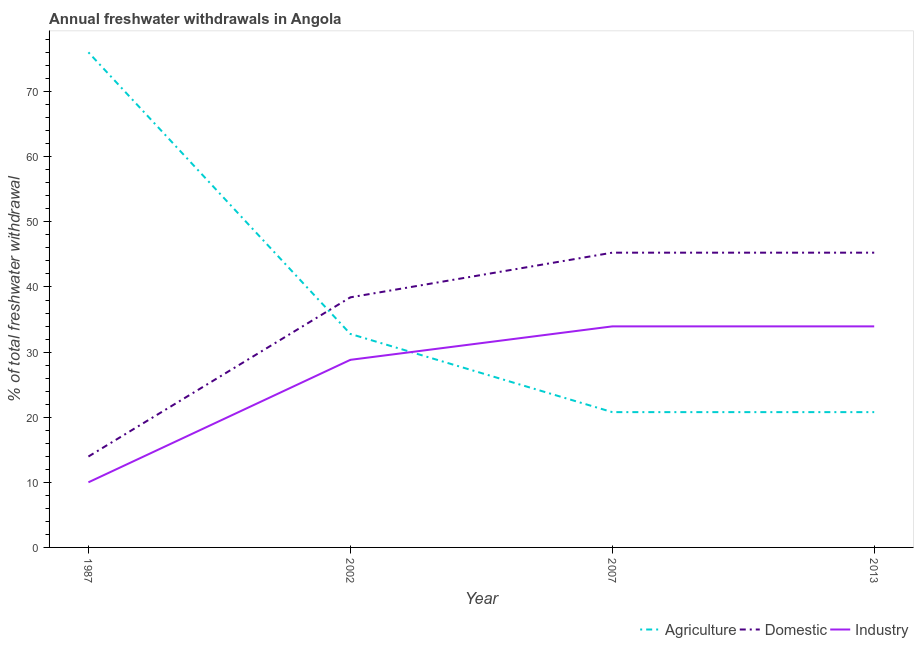How many different coloured lines are there?
Make the answer very short. 3. Does the line corresponding to percentage of freshwater withdrawal for industry intersect with the line corresponding to percentage of freshwater withdrawal for domestic purposes?
Give a very brief answer. No. Is the number of lines equal to the number of legend labels?
Provide a short and direct response. Yes. What is the percentage of freshwater withdrawal for industry in 2013?
Keep it short and to the point. 33.95. Across all years, what is the maximum percentage of freshwater withdrawal for domestic purposes?
Your answer should be very brief. 45.27. Across all years, what is the minimum percentage of freshwater withdrawal for industry?
Keep it short and to the point. 10. In which year was the percentage of freshwater withdrawal for domestic purposes maximum?
Make the answer very short. 2007. What is the total percentage of freshwater withdrawal for agriculture in the graph?
Your answer should be very brief. 150.39. What is the difference between the percentage of freshwater withdrawal for domestic purposes in 2002 and that in 2013?
Provide a succinct answer. -6.86. What is the difference between the percentage of freshwater withdrawal for domestic purposes in 2013 and the percentage of freshwater withdrawal for industry in 2007?
Your answer should be compact. 11.32. What is the average percentage of freshwater withdrawal for industry per year?
Offer a very short reply. 26.68. In the year 2007, what is the difference between the percentage of freshwater withdrawal for domestic purposes and percentage of freshwater withdrawal for industry?
Offer a very short reply. 11.32. In how many years, is the percentage of freshwater withdrawal for industry greater than 74 %?
Ensure brevity in your answer.  0. What is the ratio of the percentage of freshwater withdrawal for agriculture in 1987 to that in 2013?
Offer a terse response. 3.66. What is the difference between the highest and the second highest percentage of freshwater withdrawal for industry?
Provide a short and direct response. 0. What is the difference between the highest and the lowest percentage of freshwater withdrawal for agriculture?
Give a very brief answer. 55.26. In how many years, is the percentage of freshwater withdrawal for agriculture greater than the average percentage of freshwater withdrawal for agriculture taken over all years?
Your answer should be compact. 1. Is it the case that in every year, the sum of the percentage of freshwater withdrawal for agriculture and percentage of freshwater withdrawal for domestic purposes is greater than the percentage of freshwater withdrawal for industry?
Your response must be concise. Yes. Does the percentage of freshwater withdrawal for domestic purposes monotonically increase over the years?
Provide a succinct answer. No. Are the values on the major ticks of Y-axis written in scientific E-notation?
Keep it short and to the point. No. How many legend labels are there?
Offer a very short reply. 3. How are the legend labels stacked?
Offer a terse response. Horizontal. What is the title of the graph?
Your answer should be compact. Annual freshwater withdrawals in Angola. What is the label or title of the Y-axis?
Keep it short and to the point. % of total freshwater withdrawal. What is the % of total freshwater withdrawal in Agriculture in 1987?
Make the answer very short. 76.04. What is the % of total freshwater withdrawal of Domestic in 1987?
Your answer should be very brief. 13.96. What is the % of total freshwater withdrawal of Industry in 1987?
Your answer should be compact. 10. What is the % of total freshwater withdrawal in Agriculture in 2002?
Your response must be concise. 32.79. What is the % of total freshwater withdrawal of Domestic in 2002?
Your answer should be very brief. 38.41. What is the % of total freshwater withdrawal of Industry in 2002?
Offer a terse response. 28.81. What is the % of total freshwater withdrawal of Agriculture in 2007?
Offer a terse response. 20.78. What is the % of total freshwater withdrawal of Domestic in 2007?
Provide a succinct answer. 45.27. What is the % of total freshwater withdrawal in Industry in 2007?
Your answer should be very brief. 33.95. What is the % of total freshwater withdrawal in Agriculture in 2013?
Provide a short and direct response. 20.78. What is the % of total freshwater withdrawal of Domestic in 2013?
Your response must be concise. 45.27. What is the % of total freshwater withdrawal of Industry in 2013?
Offer a terse response. 33.95. Across all years, what is the maximum % of total freshwater withdrawal in Agriculture?
Provide a short and direct response. 76.04. Across all years, what is the maximum % of total freshwater withdrawal of Domestic?
Ensure brevity in your answer.  45.27. Across all years, what is the maximum % of total freshwater withdrawal of Industry?
Offer a very short reply. 33.95. Across all years, what is the minimum % of total freshwater withdrawal of Agriculture?
Provide a succinct answer. 20.78. Across all years, what is the minimum % of total freshwater withdrawal in Domestic?
Your answer should be very brief. 13.96. What is the total % of total freshwater withdrawal in Agriculture in the graph?
Your answer should be very brief. 150.39. What is the total % of total freshwater withdrawal of Domestic in the graph?
Ensure brevity in your answer.  142.91. What is the total % of total freshwater withdrawal in Industry in the graph?
Provide a short and direct response. 106.71. What is the difference between the % of total freshwater withdrawal in Agriculture in 1987 and that in 2002?
Give a very brief answer. 43.25. What is the difference between the % of total freshwater withdrawal in Domestic in 1987 and that in 2002?
Provide a succinct answer. -24.45. What is the difference between the % of total freshwater withdrawal in Industry in 1987 and that in 2002?
Offer a very short reply. -18.81. What is the difference between the % of total freshwater withdrawal of Agriculture in 1987 and that in 2007?
Provide a succinct answer. 55.26. What is the difference between the % of total freshwater withdrawal of Domestic in 1987 and that in 2007?
Your answer should be very brief. -31.31. What is the difference between the % of total freshwater withdrawal in Industry in 1987 and that in 2007?
Offer a very short reply. -23.95. What is the difference between the % of total freshwater withdrawal of Agriculture in 1987 and that in 2013?
Keep it short and to the point. 55.26. What is the difference between the % of total freshwater withdrawal of Domestic in 1987 and that in 2013?
Offer a very short reply. -31.31. What is the difference between the % of total freshwater withdrawal in Industry in 1987 and that in 2013?
Offer a very short reply. -23.95. What is the difference between the % of total freshwater withdrawal of Agriculture in 2002 and that in 2007?
Offer a terse response. 12.01. What is the difference between the % of total freshwater withdrawal of Domestic in 2002 and that in 2007?
Give a very brief answer. -6.86. What is the difference between the % of total freshwater withdrawal in Industry in 2002 and that in 2007?
Ensure brevity in your answer.  -5.14. What is the difference between the % of total freshwater withdrawal in Agriculture in 2002 and that in 2013?
Provide a short and direct response. 12.01. What is the difference between the % of total freshwater withdrawal in Domestic in 2002 and that in 2013?
Make the answer very short. -6.86. What is the difference between the % of total freshwater withdrawal of Industry in 2002 and that in 2013?
Your response must be concise. -5.14. What is the difference between the % of total freshwater withdrawal of Agriculture in 2007 and that in 2013?
Your answer should be very brief. 0. What is the difference between the % of total freshwater withdrawal of Domestic in 2007 and that in 2013?
Your answer should be compact. 0. What is the difference between the % of total freshwater withdrawal in Industry in 2007 and that in 2013?
Your answer should be compact. 0. What is the difference between the % of total freshwater withdrawal of Agriculture in 1987 and the % of total freshwater withdrawal of Domestic in 2002?
Make the answer very short. 37.63. What is the difference between the % of total freshwater withdrawal of Agriculture in 1987 and the % of total freshwater withdrawal of Industry in 2002?
Make the answer very short. 47.23. What is the difference between the % of total freshwater withdrawal in Domestic in 1987 and the % of total freshwater withdrawal in Industry in 2002?
Your response must be concise. -14.85. What is the difference between the % of total freshwater withdrawal of Agriculture in 1987 and the % of total freshwater withdrawal of Domestic in 2007?
Offer a terse response. 30.77. What is the difference between the % of total freshwater withdrawal of Agriculture in 1987 and the % of total freshwater withdrawal of Industry in 2007?
Offer a very short reply. 42.09. What is the difference between the % of total freshwater withdrawal in Domestic in 1987 and the % of total freshwater withdrawal in Industry in 2007?
Offer a terse response. -19.99. What is the difference between the % of total freshwater withdrawal of Agriculture in 1987 and the % of total freshwater withdrawal of Domestic in 2013?
Your answer should be very brief. 30.77. What is the difference between the % of total freshwater withdrawal of Agriculture in 1987 and the % of total freshwater withdrawal of Industry in 2013?
Make the answer very short. 42.09. What is the difference between the % of total freshwater withdrawal of Domestic in 1987 and the % of total freshwater withdrawal of Industry in 2013?
Your answer should be compact. -19.99. What is the difference between the % of total freshwater withdrawal in Agriculture in 2002 and the % of total freshwater withdrawal in Domestic in 2007?
Give a very brief answer. -12.48. What is the difference between the % of total freshwater withdrawal in Agriculture in 2002 and the % of total freshwater withdrawal in Industry in 2007?
Keep it short and to the point. -1.16. What is the difference between the % of total freshwater withdrawal in Domestic in 2002 and the % of total freshwater withdrawal in Industry in 2007?
Your response must be concise. 4.46. What is the difference between the % of total freshwater withdrawal of Agriculture in 2002 and the % of total freshwater withdrawal of Domestic in 2013?
Provide a succinct answer. -12.48. What is the difference between the % of total freshwater withdrawal in Agriculture in 2002 and the % of total freshwater withdrawal in Industry in 2013?
Give a very brief answer. -1.16. What is the difference between the % of total freshwater withdrawal in Domestic in 2002 and the % of total freshwater withdrawal in Industry in 2013?
Give a very brief answer. 4.46. What is the difference between the % of total freshwater withdrawal of Agriculture in 2007 and the % of total freshwater withdrawal of Domestic in 2013?
Keep it short and to the point. -24.49. What is the difference between the % of total freshwater withdrawal in Agriculture in 2007 and the % of total freshwater withdrawal in Industry in 2013?
Offer a terse response. -13.17. What is the difference between the % of total freshwater withdrawal of Domestic in 2007 and the % of total freshwater withdrawal of Industry in 2013?
Offer a very short reply. 11.32. What is the average % of total freshwater withdrawal in Agriculture per year?
Provide a succinct answer. 37.6. What is the average % of total freshwater withdrawal of Domestic per year?
Provide a short and direct response. 35.73. What is the average % of total freshwater withdrawal of Industry per year?
Your response must be concise. 26.68. In the year 1987, what is the difference between the % of total freshwater withdrawal in Agriculture and % of total freshwater withdrawal in Domestic?
Provide a succinct answer. 62.08. In the year 1987, what is the difference between the % of total freshwater withdrawal of Agriculture and % of total freshwater withdrawal of Industry?
Give a very brief answer. 66.04. In the year 1987, what is the difference between the % of total freshwater withdrawal of Domestic and % of total freshwater withdrawal of Industry?
Your response must be concise. 3.96. In the year 2002, what is the difference between the % of total freshwater withdrawal in Agriculture and % of total freshwater withdrawal in Domestic?
Offer a terse response. -5.62. In the year 2002, what is the difference between the % of total freshwater withdrawal in Agriculture and % of total freshwater withdrawal in Industry?
Make the answer very short. 3.98. In the year 2007, what is the difference between the % of total freshwater withdrawal in Agriculture and % of total freshwater withdrawal in Domestic?
Provide a short and direct response. -24.49. In the year 2007, what is the difference between the % of total freshwater withdrawal in Agriculture and % of total freshwater withdrawal in Industry?
Provide a succinct answer. -13.17. In the year 2007, what is the difference between the % of total freshwater withdrawal in Domestic and % of total freshwater withdrawal in Industry?
Your answer should be compact. 11.32. In the year 2013, what is the difference between the % of total freshwater withdrawal of Agriculture and % of total freshwater withdrawal of Domestic?
Your response must be concise. -24.49. In the year 2013, what is the difference between the % of total freshwater withdrawal in Agriculture and % of total freshwater withdrawal in Industry?
Provide a succinct answer. -13.17. In the year 2013, what is the difference between the % of total freshwater withdrawal of Domestic and % of total freshwater withdrawal of Industry?
Provide a short and direct response. 11.32. What is the ratio of the % of total freshwater withdrawal of Agriculture in 1987 to that in 2002?
Provide a short and direct response. 2.32. What is the ratio of the % of total freshwater withdrawal in Domestic in 1987 to that in 2002?
Ensure brevity in your answer.  0.36. What is the ratio of the % of total freshwater withdrawal of Industry in 1987 to that in 2002?
Provide a succinct answer. 0.35. What is the ratio of the % of total freshwater withdrawal in Agriculture in 1987 to that in 2007?
Make the answer very short. 3.66. What is the ratio of the % of total freshwater withdrawal of Domestic in 1987 to that in 2007?
Make the answer very short. 0.31. What is the ratio of the % of total freshwater withdrawal of Industry in 1987 to that in 2007?
Keep it short and to the point. 0.29. What is the ratio of the % of total freshwater withdrawal of Agriculture in 1987 to that in 2013?
Offer a very short reply. 3.66. What is the ratio of the % of total freshwater withdrawal of Domestic in 1987 to that in 2013?
Ensure brevity in your answer.  0.31. What is the ratio of the % of total freshwater withdrawal of Industry in 1987 to that in 2013?
Ensure brevity in your answer.  0.29. What is the ratio of the % of total freshwater withdrawal of Agriculture in 2002 to that in 2007?
Your response must be concise. 1.58. What is the ratio of the % of total freshwater withdrawal of Domestic in 2002 to that in 2007?
Offer a very short reply. 0.85. What is the ratio of the % of total freshwater withdrawal in Industry in 2002 to that in 2007?
Keep it short and to the point. 0.85. What is the ratio of the % of total freshwater withdrawal of Agriculture in 2002 to that in 2013?
Give a very brief answer. 1.58. What is the ratio of the % of total freshwater withdrawal in Domestic in 2002 to that in 2013?
Your answer should be very brief. 0.85. What is the ratio of the % of total freshwater withdrawal in Industry in 2002 to that in 2013?
Make the answer very short. 0.85. What is the difference between the highest and the second highest % of total freshwater withdrawal in Agriculture?
Provide a succinct answer. 43.25. What is the difference between the highest and the lowest % of total freshwater withdrawal in Agriculture?
Provide a succinct answer. 55.26. What is the difference between the highest and the lowest % of total freshwater withdrawal of Domestic?
Make the answer very short. 31.31. What is the difference between the highest and the lowest % of total freshwater withdrawal in Industry?
Make the answer very short. 23.95. 